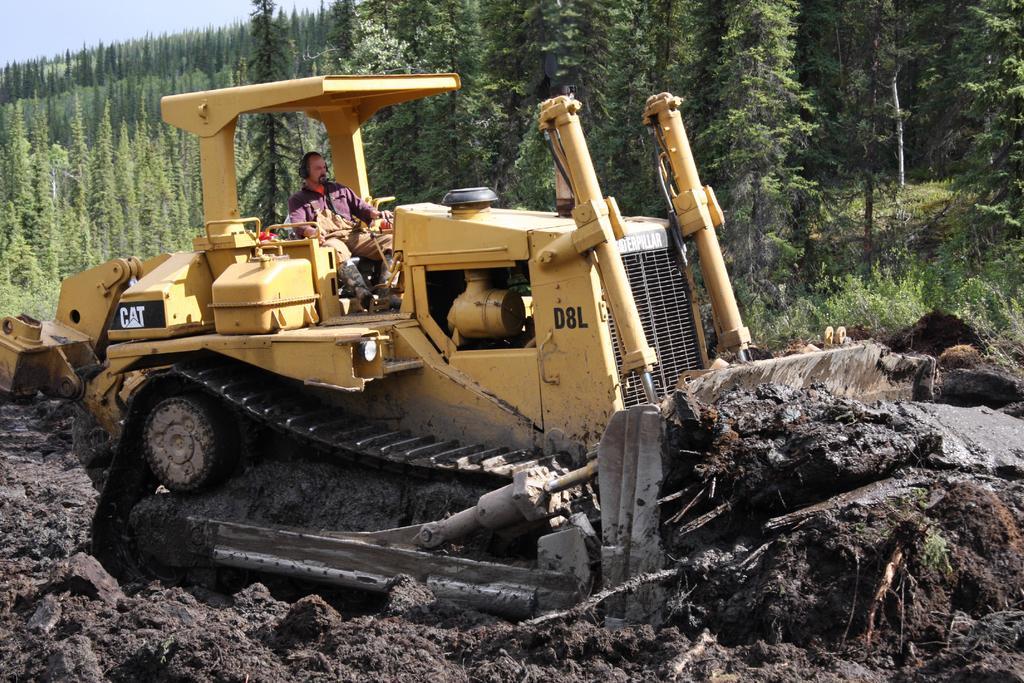Could you give a brief overview of what you see in this image? In the middle of the picture, we see a man riding the bulldozer. It is in yellow color. At the bottom of the picture, we see the mud. There are trees in the background. 